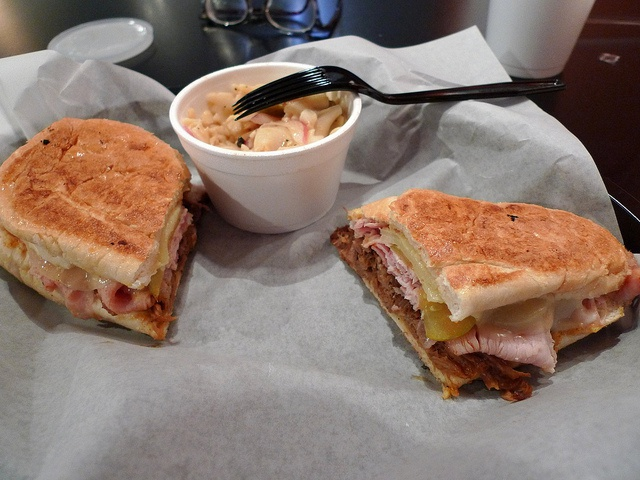Describe the objects in this image and their specific colors. I can see sandwich in tan, gray, maroon, and brown tones, sandwich in tan, brown, gray, and salmon tones, dining table in tan, black, and gray tones, bowl in tan, darkgray, and gray tones, and cup in tan, darkgray, and gray tones in this image. 